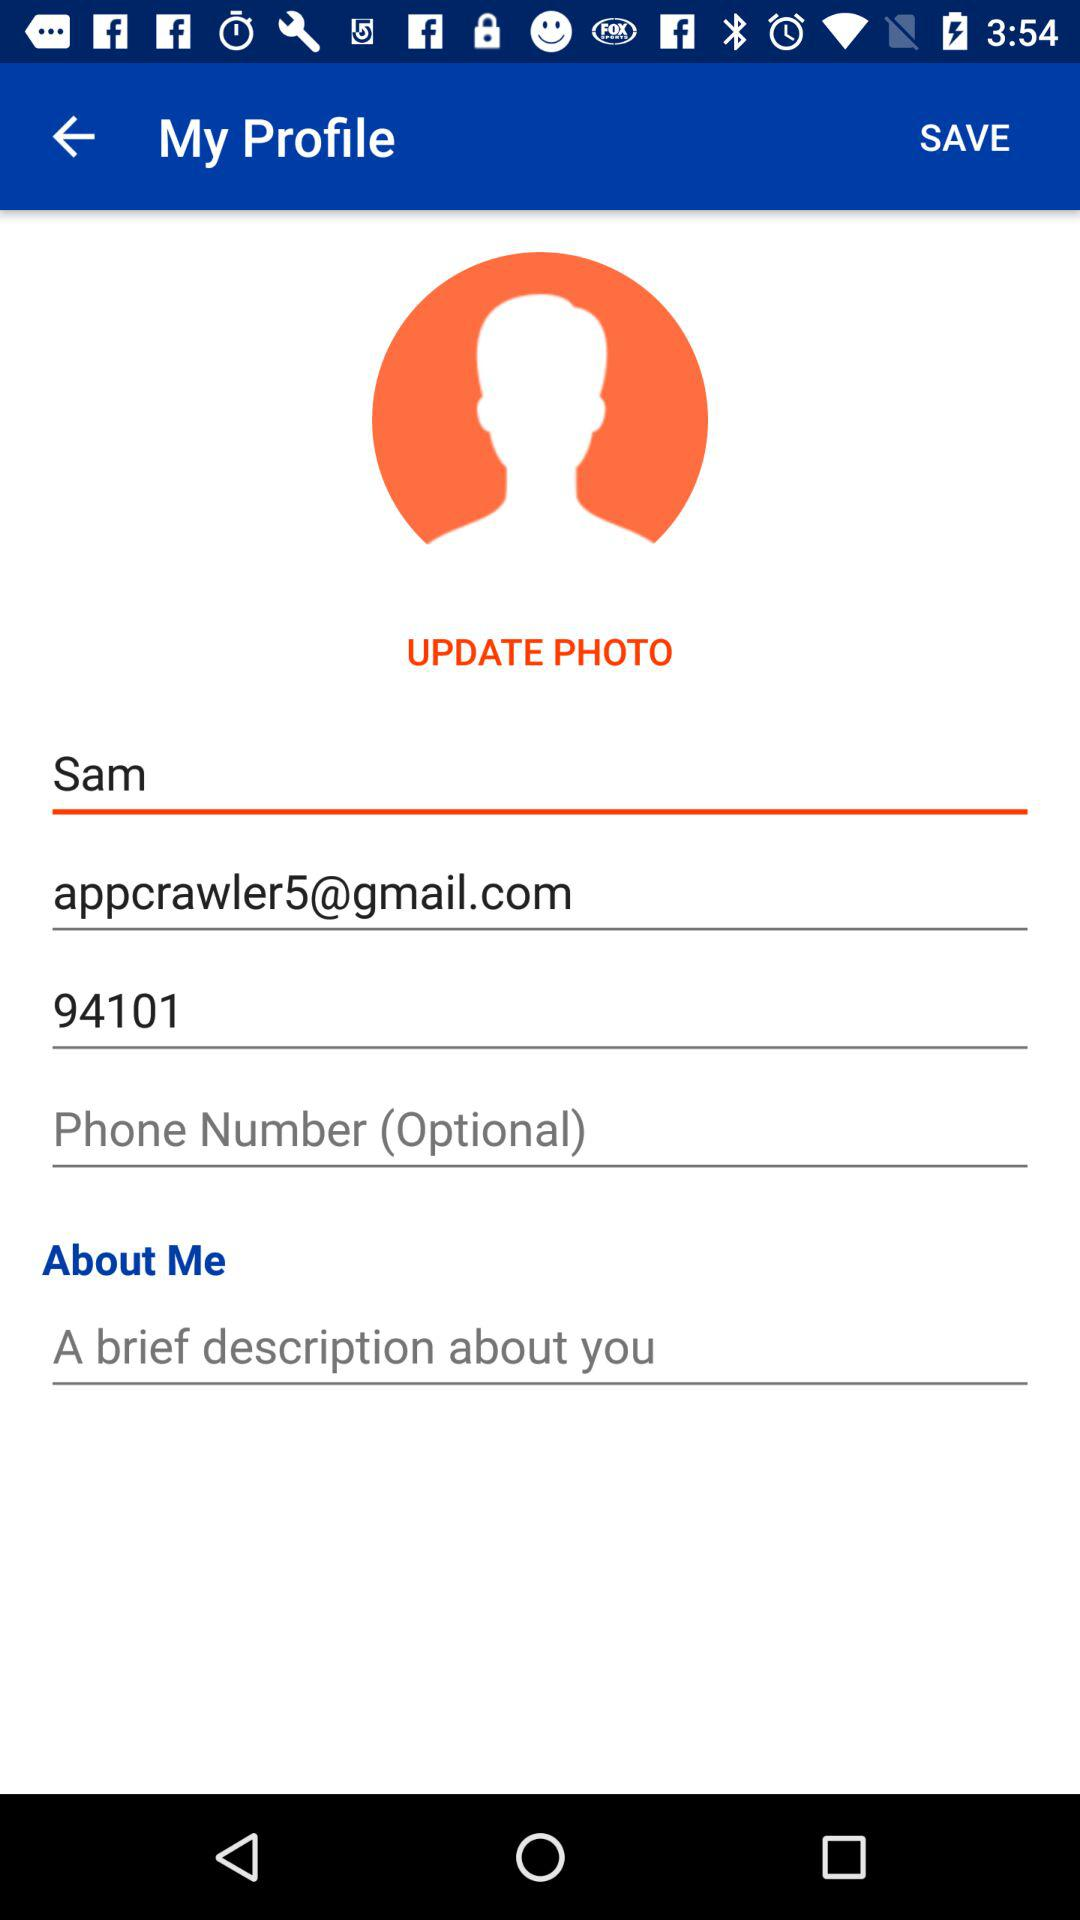What is the name? The name is Sam. 